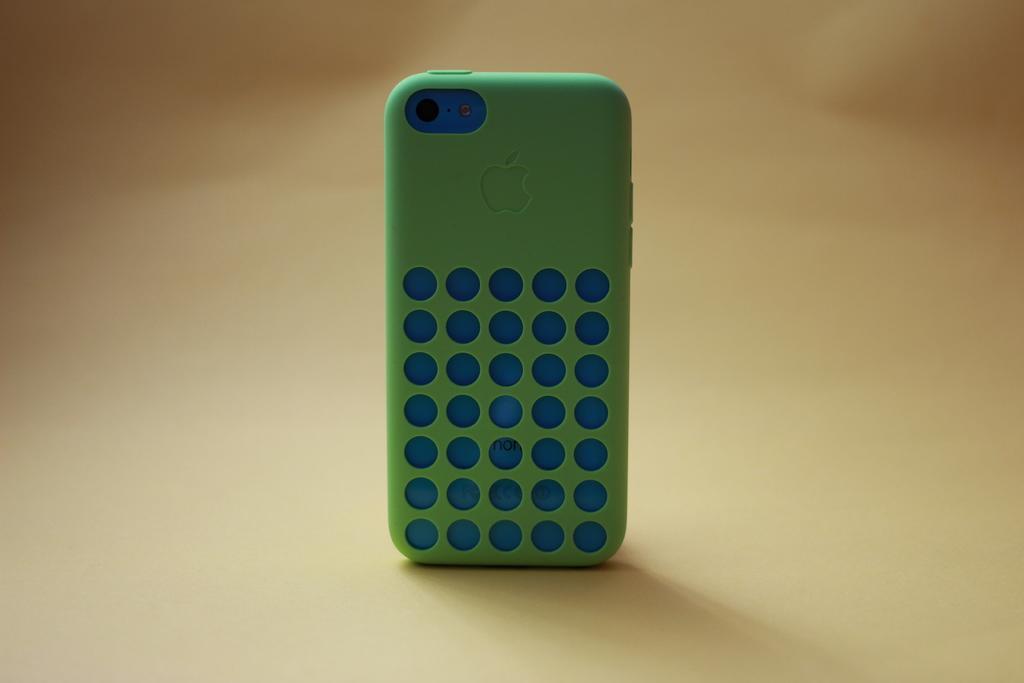Describe this image in one or two sentences. In this image there is an apple mobile with a green colour back case. 